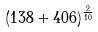Convert formula to latex. <formula><loc_0><loc_0><loc_500><loc_500>( 1 3 8 + 4 0 6 ) ^ { \frac { 2 } { 1 0 } }</formula> 